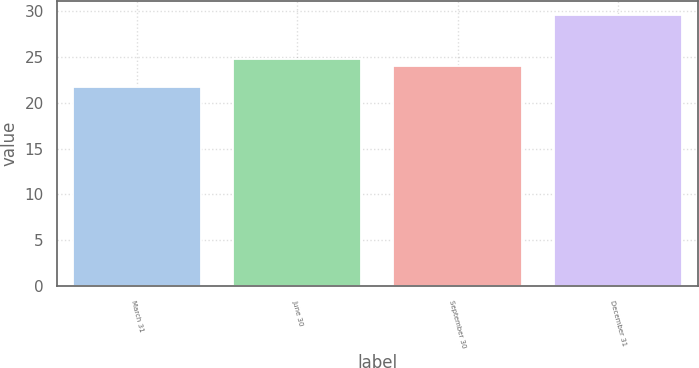Convert chart to OTSL. <chart><loc_0><loc_0><loc_500><loc_500><bar_chart><fcel>March 31<fcel>June 30<fcel>September 30<fcel>December 31<nl><fcel>21.7<fcel>24.79<fcel>24<fcel>29.6<nl></chart> 